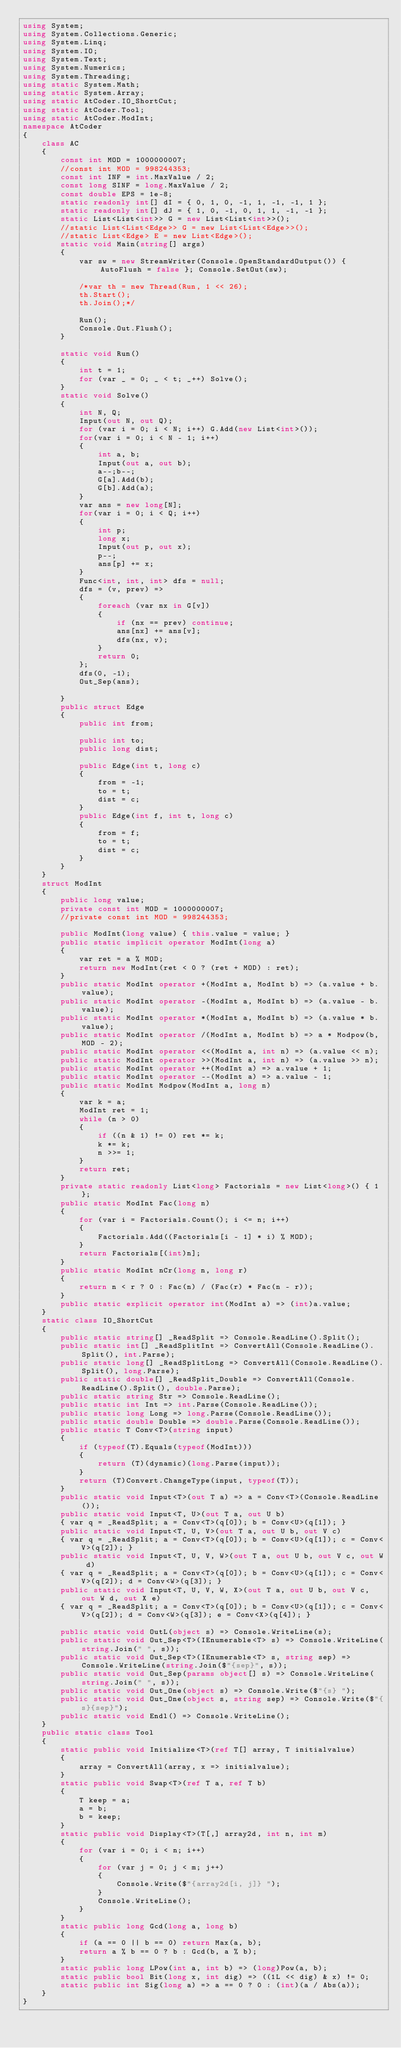Convert code to text. <code><loc_0><loc_0><loc_500><loc_500><_C#_>using System;
using System.Collections.Generic;
using System.Linq;
using System.IO;
using System.Text;
using System.Numerics;
using System.Threading;
using static System.Math;
using static System.Array;
using static AtCoder.IO_ShortCut;
using static AtCoder.Tool;
using static AtCoder.ModInt;
namespace AtCoder
{
    class AC
    {
        const int MOD = 1000000007;
        //const int MOD = 998244353;
        const int INF = int.MaxValue / 2;
        const long SINF = long.MaxValue / 2;
        const double EPS = 1e-8;
        static readonly int[] dI = { 0, 1, 0, -1, 1, -1, -1, 1 };
        static readonly int[] dJ = { 1, 0, -1, 0, 1, 1, -1, -1 };
        static List<List<int>> G = new List<List<int>>();
        //static List<List<Edge>> G = new List<List<Edge>>();
        //static List<Edge> E = new List<Edge>();
        static void Main(string[] args)
        {
            var sw = new StreamWriter(Console.OpenStandardOutput()) { AutoFlush = false }; Console.SetOut(sw);

            /*var th = new Thread(Run, 1 << 26);
            th.Start();
            th.Join();*/

            Run();
            Console.Out.Flush();
        }

        static void Run()
        {
            int t = 1;
            for (var _ = 0; _ < t; _++) Solve();
        }
        static void Solve()
        {
            int N, Q;
            Input(out N, out Q);
            for (var i = 0; i < N; i++) G.Add(new List<int>());
            for(var i = 0; i < N - 1; i++)
            {
                int a, b;
                Input(out a, out b);
                a--;b--;
                G[a].Add(b);
                G[b].Add(a);
            }
            var ans = new long[N];
            for(var i = 0; i < Q; i++)
            {
                int p;
                long x;
                Input(out p, out x);
                p--;
                ans[p] += x;
            }
            Func<int, int, int> dfs = null;
            dfs = (v, prev) =>
            {
                foreach (var nx in G[v])
                {
                    if (nx == prev) continue;
                    ans[nx] += ans[v];
                    dfs(nx, v);
                }
                return 0;
            };
            dfs(0, -1);
            Out_Sep(ans);

        }
        public struct Edge
        {
            public int from;

            public int to;
            public long dist;

            public Edge(int t, long c)
            {
                from = -1;
                to = t;
                dist = c;
            }
            public Edge(int f, int t, long c)
            {
                from = f;
                to = t;
                dist = c;
            }
        }
    }
    struct ModInt
    {
        public long value;
        private const int MOD = 1000000007;
        //private const int MOD = 998244353;

        public ModInt(long value) { this.value = value; }
        public static implicit operator ModInt(long a)
        {
            var ret = a % MOD;
            return new ModInt(ret < 0 ? (ret + MOD) : ret);
        }
        public static ModInt operator +(ModInt a, ModInt b) => (a.value + b.value);
        public static ModInt operator -(ModInt a, ModInt b) => (a.value - b.value);
        public static ModInt operator *(ModInt a, ModInt b) => (a.value * b.value);
        public static ModInt operator /(ModInt a, ModInt b) => a * Modpow(b, MOD - 2);
        public static ModInt operator <<(ModInt a, int n) => (a.value << n);
        public static ModInt operator >>(ModInt a, int n) => (a.value >> n);
        public static ModInt operator ++(ModInt a) => a.value + 1;
        public static ModInt operator --(ModInt a) => a.value - 1;
        public static ModInt Modpow(ModInt a, long n)
        {
            var k = a;
            ModInt ret = 1;
            while (n > 0)
            {
                if ((n & 1) != 0) ret *= k;
                k *= k;
                n >>= 1;
            }
            return ret;
        }
        private static readonly List<long> Factorials = new List<long>() { 1 };
        public static ModInt Fac(long n)
        {
            for (var i = Factorials.Count(); i <= n; i++)
            {
                Factorials.Add((Factorials[i - 1] * i) % MOD);
            }
            return Factorials[(int)n];
        }
        public static ModInt nCr(long n, long r)
        {
            return n < r ? 0 : Fac(n) / (Fac(r) * Fac(n - r));
        }
        public static explicit operator int(ModInt a) => (int)a.value;
    }
    static class IO_ShortCut
    {
        public static string[] _ReadSplit => Console.ReadLine().Split();
        public static int[] _ReadSplitInt => ConvertAll(Console.ReadLine().Split(), int.Parse);
        public static long[] _ReadSplitLong => ConvertAll(Console.ReadLine().Split(), long.Parse);
        public static double[] _ReadSplit_Double => ConvertAll(Console.ReadLine().Split(), double.Parse);
        public static string Str => Console.ReadLine();
        public static int Int => int.Parse(Console.ReadLine());
        public static long Long => long.Parse(Console.ReadLine());
        public static double Double => double.Parse(Console.ReadLine());
        public static T Conv<T>(string input)
        {
            if (typeof(T).Equals(typeof(ModInt)))
            {
                return (T)(dynamic)(long.Parse(input));
            }
            return (T)Convert.ChangeType(input, typeof(T));
        }
        public static void Input<T>(out T a) => a = Conv<T>(Console.ReadLine());
        public static void Input<T, U>(out T a, out U b)
        { var q = _ReadSplit; a = Conv<T>(q[0]); b = Conv<U>(q[1]); }
        public static void Input<T, U, V>(out T a, out U b, out V c)
        { var q = _ReadSplit; a = Conv<T>(q[0]); b = Conv<U>(q[1]); c = Conv<V>(q[2]); }
        public static void Input<T, U, V, W>(out T a, out U b, out V c, out W d)
        { var q = _ReadSplit; a = Conv<T>(q[0]); b = Conv<U>(q[1]); c = Conv<V>(q[2]); d = Conv<W>(q[3]); }
        public static void Input<T, U, V, W, X>(out T a, out U b, out V c, out W d, out X e)
        { var q = _ReadSplit; a = Conv<T>(q[0]); b = Conv<U>(q[1]); c = Conv<V>(q[2]); d = Conv<W>(q[3]); e = Conv<X>(q[4]); }

        public static void OutL(object s) => Console.WriteLine(s);
        public static void Out_Sep<T>(IEnumerable<T> s) => Console.WriteLine(string.Join(" ", s));
        public static void Out_Sep<T>(IEnumerable<T> s, string sep) => Console.WriteLine(string.Join($"{sep}", s));
        public static void Out_Sep(params object[] s) => Console.WriteLine(string.Join(" ", s));
        public static void Out_One(object s) => Console.Write($"{s} ");
        public static void Out_One(object s, string sep) => Console.Write($"{s}{sep}");
        public static void Endl() => Console.WriteLine();
    }
    public static class Tool
    {
        static public void Initialize<T>(ref T[] array, T initialvalue)
        {
            array = ConvertAll(array, x => initialvalue);
        }
        static public void Swap<T>(ref T a, ref T b)
        {
            T keep = a;
            a = b;
            b = keep;
        }
        static public void Display<T>(T[,] array2d, int n, int m)
        {
            for (var i = 0; i < n; i++)
            {
                for (var j = 0; j < m; j++)
                {
                    Console.Write($"{array2d[i, j]} ");
                }
                Console.WriteLine();
            }
        }
        static public long Gcd(long a, long b)
        {
            if (a == 0 || b == 0) return Max(a, b);
            return a % b == 0 ? b : Gcd(b, a % b);
        }
        static public long LPow(int a, int b) => (long)Pow(a, b);
        static public bool Bit(long x, int dig) => ((1L << dig) & x) != 0;
        static public int Sig(long a) => a == 0 ? 0 : (int)(a / Abs(a));
    }
}
</code> 